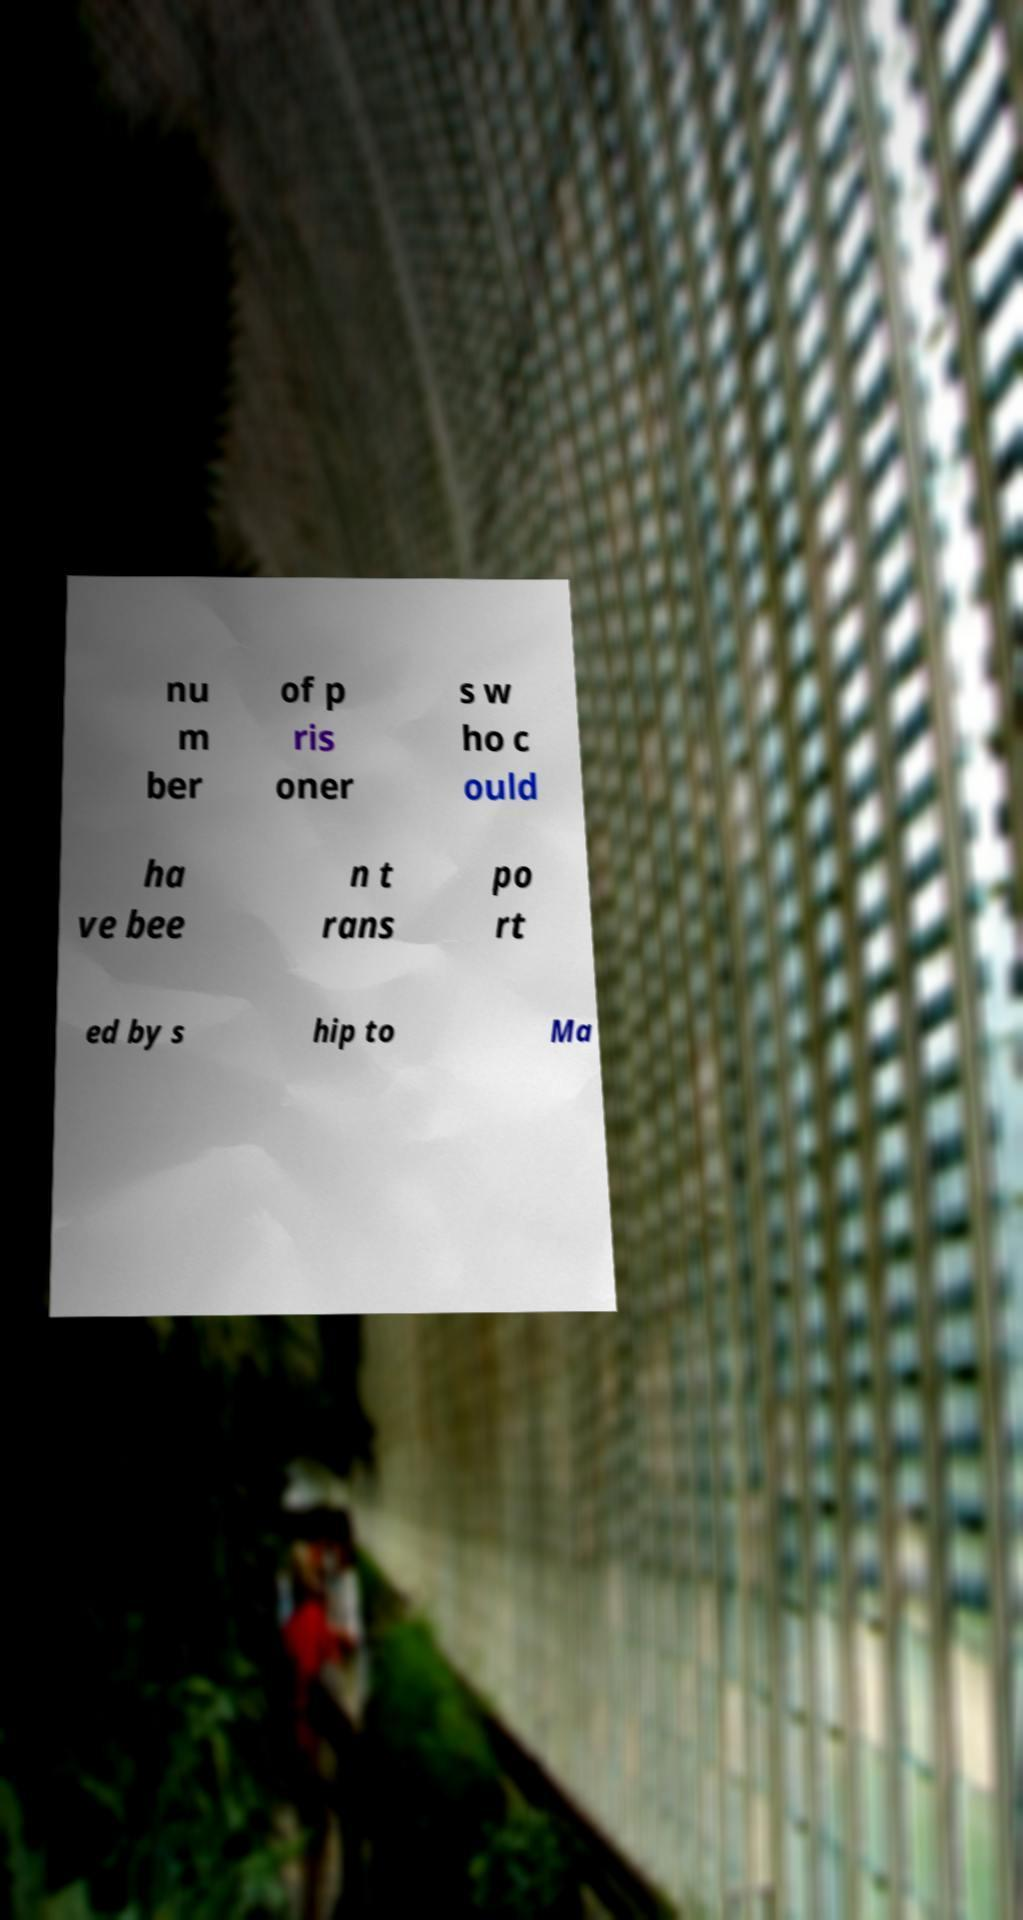Could you assist in decoding the text presented in this image and type it out clearly? nu m ber of p ris oner s w ho c ould ha ve bee n t rans po rt ed by s hip to Ma 